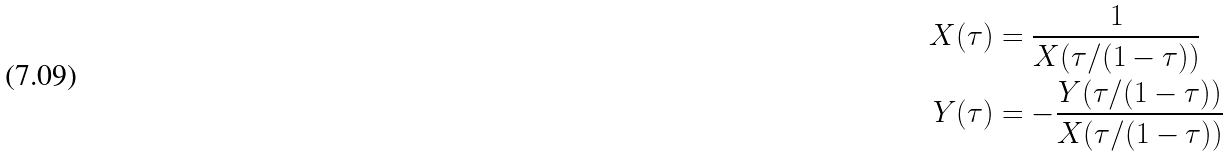Convert formula to latex. <formula><loc_0><loc_0><loc_500><loc_500>X ( \tau ) & = \frac { 1 } { X ( \tau / ( 1 - \tau ) ) } \\ Y ( \tau ) & = - \frac { Y ( \tau / ( 1 - \tau ) ) } { X ( \tau / ( 1 - \tau ) ) }</formula> 